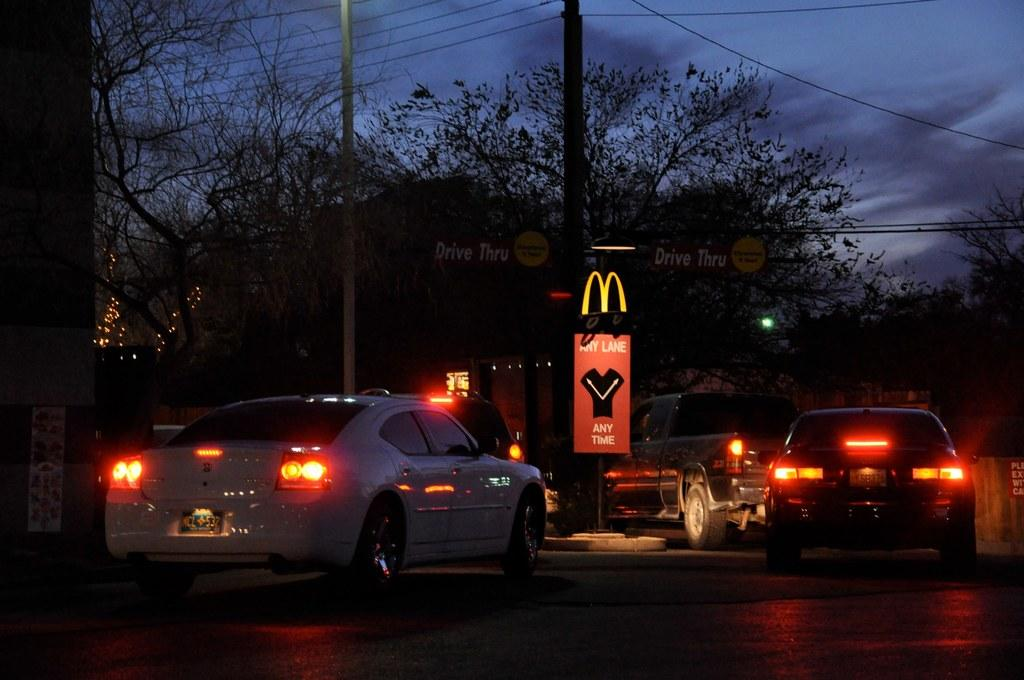What type of vegetation can be seen in the image? There are trees in the image. What type of man-made objects are present in the image? There are cars in the image. What additional feature can be seen in the image? There is a banner in the image. What is visible at the top of the image? The sky is visible at the top of the image. Can you tell me how many porters are carrying luggage in the image? There are no porters carrying luggage in the image; it features trees, cars, a banner, and the sky. What type of haircut is the wilderness receiving in the image? There is no wilderness or haircut present in the image. 